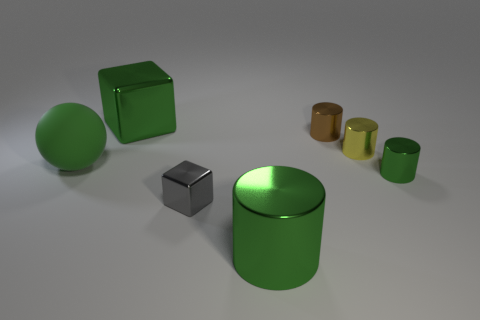Could you describe how the lighting affects the appearance of these objects? Certainly, the lighting in the image is soft and diffused, coming from above, which creates gentle shadows beneath the objects, giving them a grounded appearance in the space. The reflective surfaces of the green objects catch the light, highlighting their curves and contours, while the matte surfaces of the gray objects diffuse the light, softening their appearance. Does the lighting suggest anything about the time of day or setting? The neutral and controlled lighting suggests an indoor setting, possibly a studio where the light source is designed to avoid harsh shadows. It does not resemble natural lighting from a particular time of day but rather an artificial scenario meant for showcasing the objects without environmental interference. 